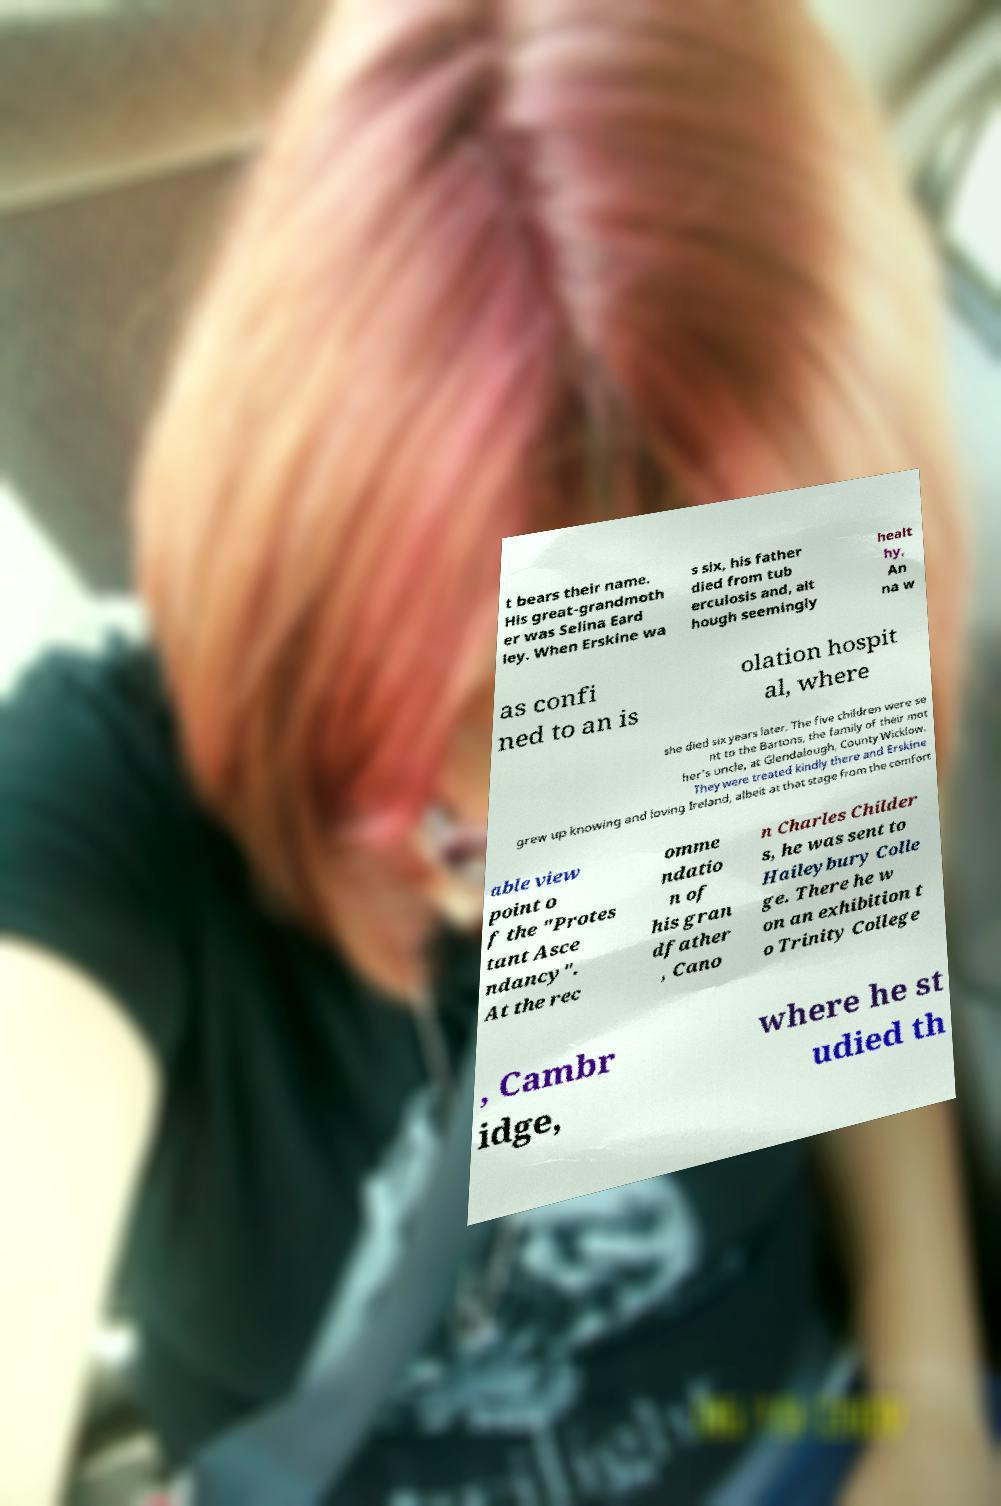For documentation purposes, I need the text within this image transcribed. Could you provide that? t bears their name. His great-grandmoth er was Selina Eard ley. When Erskine wa s six, his father died from tub erculosis and, alt hough seemingly healt hy, An na w as confi ned to an is olation hospit al, where she died six years later. The five children were se nt to the Bartons, the family of their mot her’s uncle, at Glendalough, County Wicklow. They were treated kindly there and Erskine grew up knowing and loving Ireland, albeit at that stage from the comfort able view point o f the "Protes tant Asce ndancy". At the rec omme ndatio n of his gran dfather , Cano n Charles Childer s, he was sent to Haileybury Colle ge. There he w on an exhibition t o Trinity College , Cambr idge, where he st udied th 